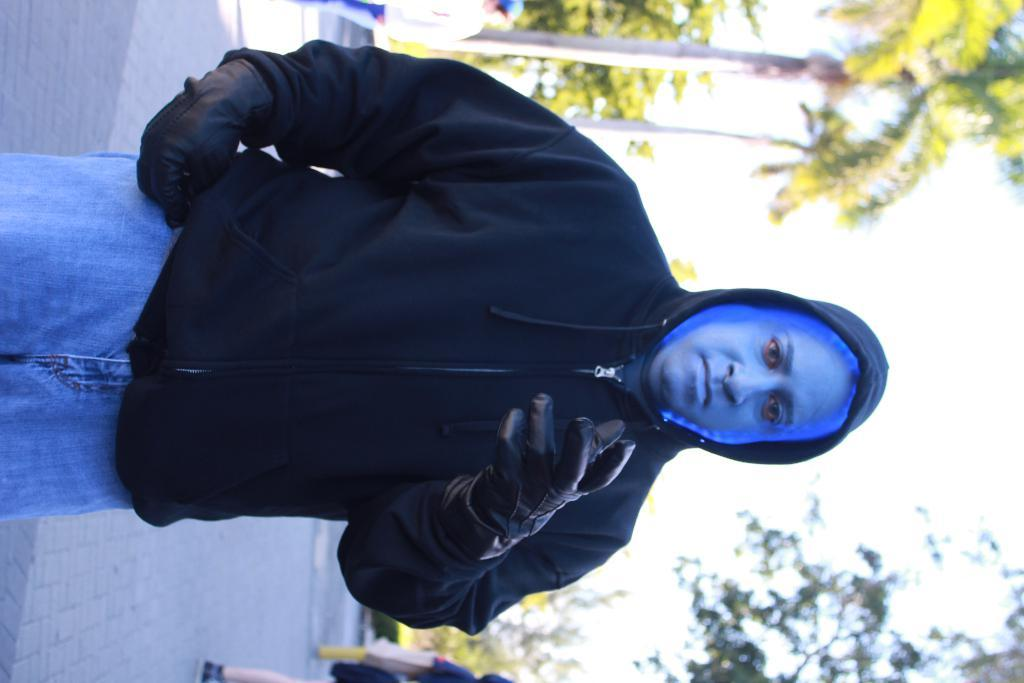What is the man in the image wearing on his hands? The man in the image is wearing gloves. What can be seen in the background of the image? There are people standing and trees visible in the background of the image. What is visible in the sky in the image? The sky is visible in the background of the image. How many fans are visible in the image? There are no fans present in the image. What type of addition is being made to the image? There is no addition being made to the image; it is a static photograph. 